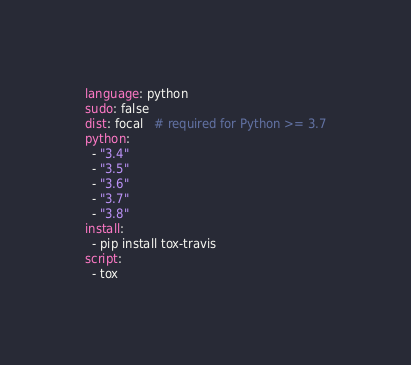<code> <loc_0><loc_0><loc_500><loc_500><_YAML_>language: python
sudo: false
dist: focal   # required for Python >= 3.7
python:
  - "3.4"
  - "3.5"
  - "3.6"
  - "3.7"
  - "3.8"
install:
  - pip install tox-travis
script:
  - tox
</code> 